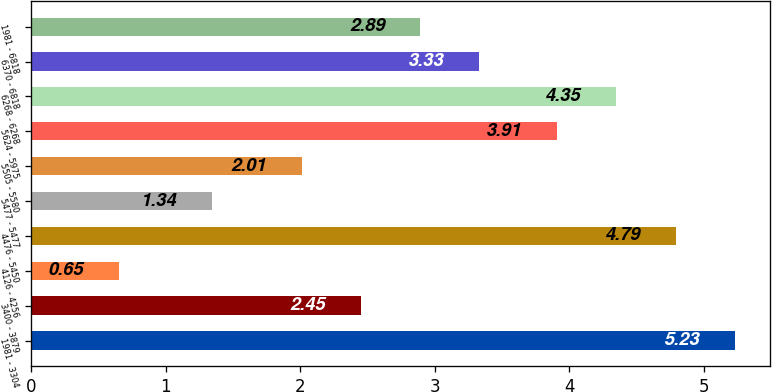<chart> <loc_0><loc_0><loc_500><loc_500><bar_chart><fcel>1981 - 3304<fcel>3400 - 3879<fcel>4126 - 4256<fcel>4476 - 5450<fcel>5477 - 5477<fcel>5505 - 5580<fcel>5624 - 5975<fcel>6268 - 6268<fcel>6370 - 6818<fcel>1981 - 6818<nl><fcel>5.23<fcel>2.45<fcel>0.65<fcel>4.79<fcel>1.34<fcel>2.01<fcel>3.91<fcel>4.35<fcel>3.33<fcel>2.89<nl></chart> 